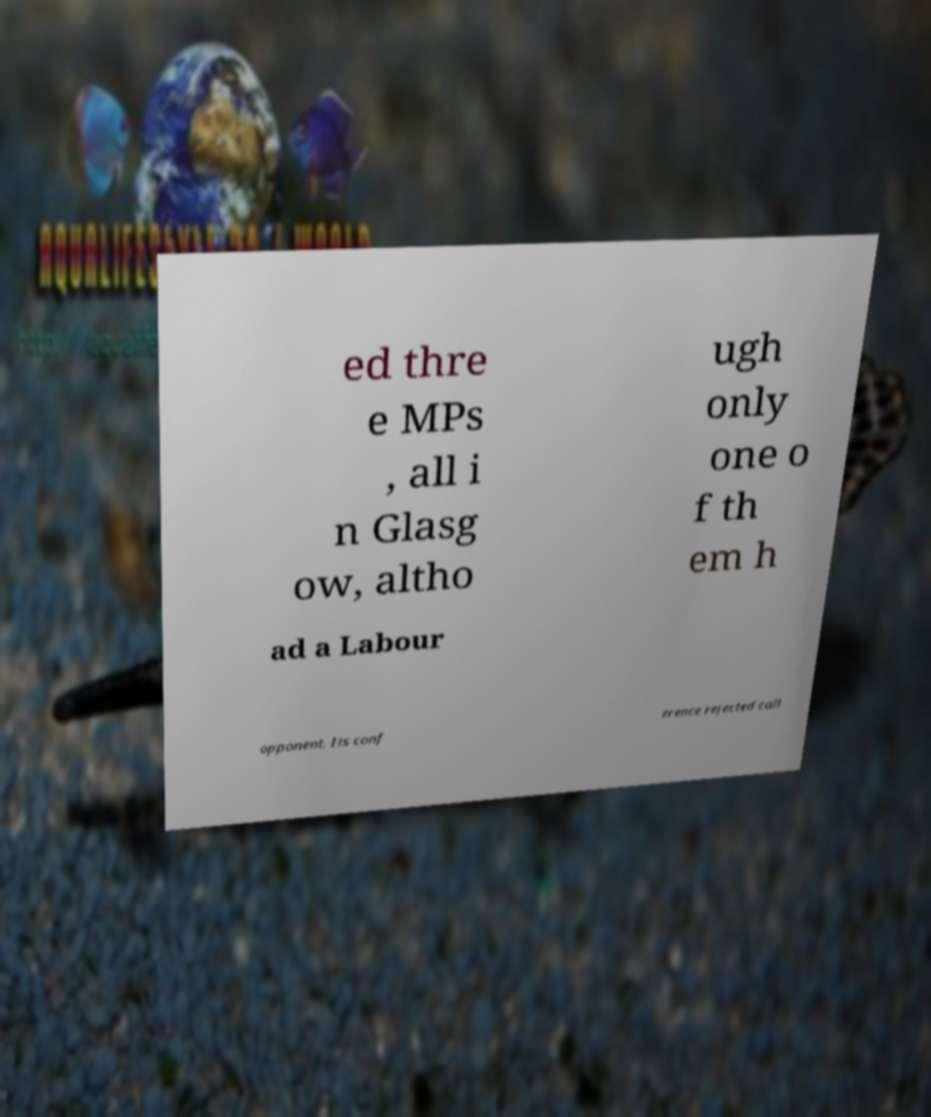What messages or text are displayed in this image? I need them in a readable, typed format. ed thre e MPs , all i n Glasg ow, altho ugh only one o f th em h ad a Labour opponent. Its conf erence rejected call 